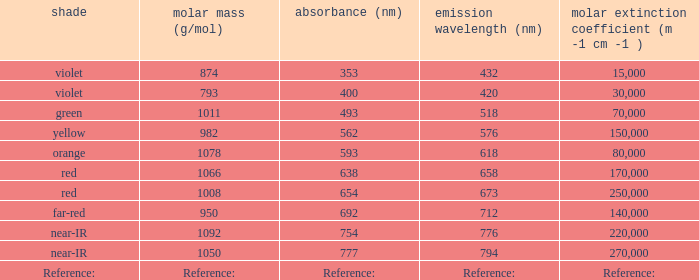What is the Absorbtion (in nanometers) of the color Violet with an emission of 432 nm? 353.0. 